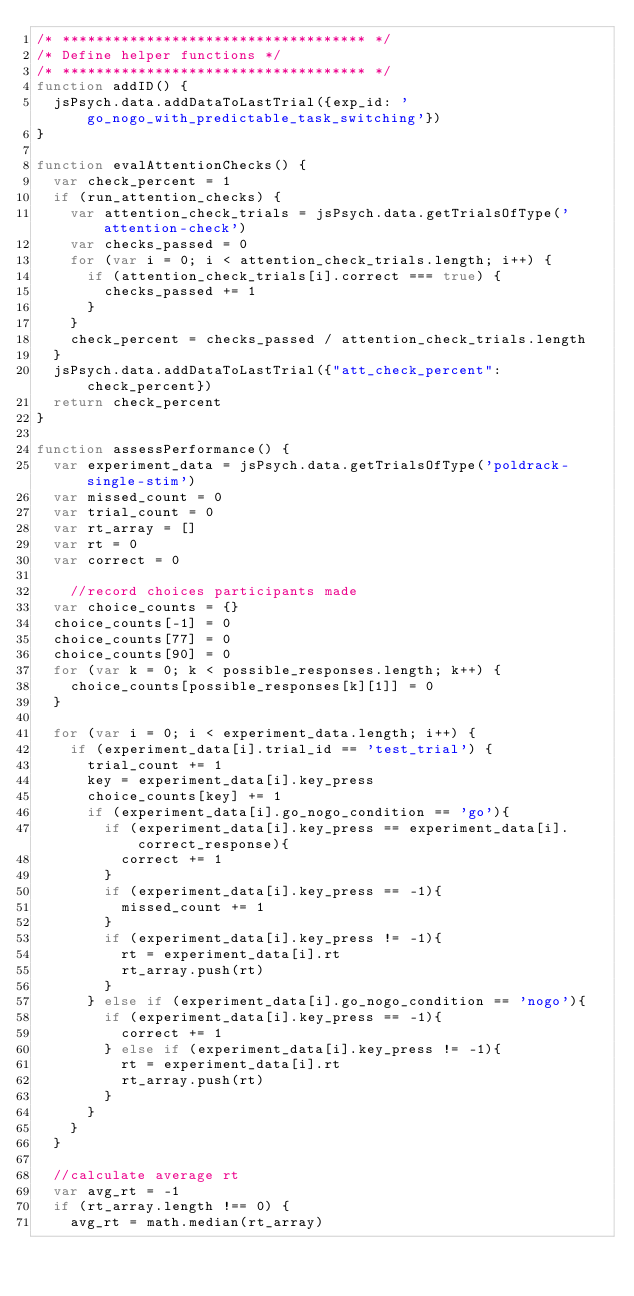Convert code to text. <code><loc_0><loc_0><loc_500><loc_500><_JavaScript_>/* ************************************ */
/* Define helper functions */
/* ************************************ */
function addID() {
  jsPsych.data.addDataToLastTrial({exp_id: 'go_nogo_with_predictable_task_switching'})
}

function evalAttentionChecks() {
  var check_percent = 1
  if (run_attention_checks) {
    var attention_check_trials = jsPsych.data.getTrialsOfType('attention-check')
    var checks_passed = 0
    for (var i = 0; i < attention_check_trials.length; i++) {
      if (attention_check_trials[i].correct === true) {
        checks_passed += 1
      }
    }
    check_percent = checks_passed / attention_check_trials.length
  }
  jsPsych.data.addDataToLastTrial({"att_check_percent": check_percent})
  return check_percent
}

function assessPerformance() {
	var experiment_data = jsPsych.data.getTrialsOfType('poldrack-single-stim')
	var missed_count = 0
	var trial_count = 0
	var rt_array = []
	var rt = 0
	var correct = 0

		//record choices participants made
	var choice_counts = {}
	choice_counts[-1] = 0
	choice_counts[77] = 0
	choice_counts[90] = 0
	for (var k = 0; k < possible_responses.length; k++) {
		choice_counts[possible_responses[k][1]] = 0
	}
	
	for (var i = 0; i < experiment_data.length; i++) {
		if (experiment_data[i].trial_id == 'test_trial') {
			trial_count += 1
			key = experiment_data[i].key_press
			choice_counts[key] += 1
			if (experiment_data[i].go_nogo_condition == 'go'){
				if (experiment_data[i].key_press == experiment_data[i].correct_response){
					correct += 1
				}
				if (experiment_data[i].key_press == -1){
					missed_count += 1
				}
				if (experiment_data[i].key_press != -1){
					rt = experiment_data[i].rt
					rt_array.push(rt)
				}
			} else if (experiment_data[i].go_nogo_condition == 'nogo'){
				if (experiment_data[i].key_press == -1){
					correct += 1
				} else if (experiment_data[i].key_press != -1){
					rt = experiment_data[i].rt
					rt_array.push(rt)
				}
			}
		}	
	}
	
	//calculate average rt
	var avg_rt = -1
	if (rt_array.length !== 0) {
		avg_rt = math.median(rt_array)</code> 